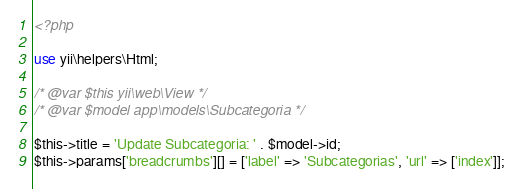<code> <loc_0><loc_0><loc_500><loc_500><_PHP_><?php

use yii\helpers\Html;

/* @var $this yii\web\View */
/* @var $model app\models\Subcategoria */

$this->title = 'Update Subcategoria: ' . $model->id;
$this->params['breadcrumbs'][] = ['label' => 'Subcategorias', 'url' => ['index']];</code> 